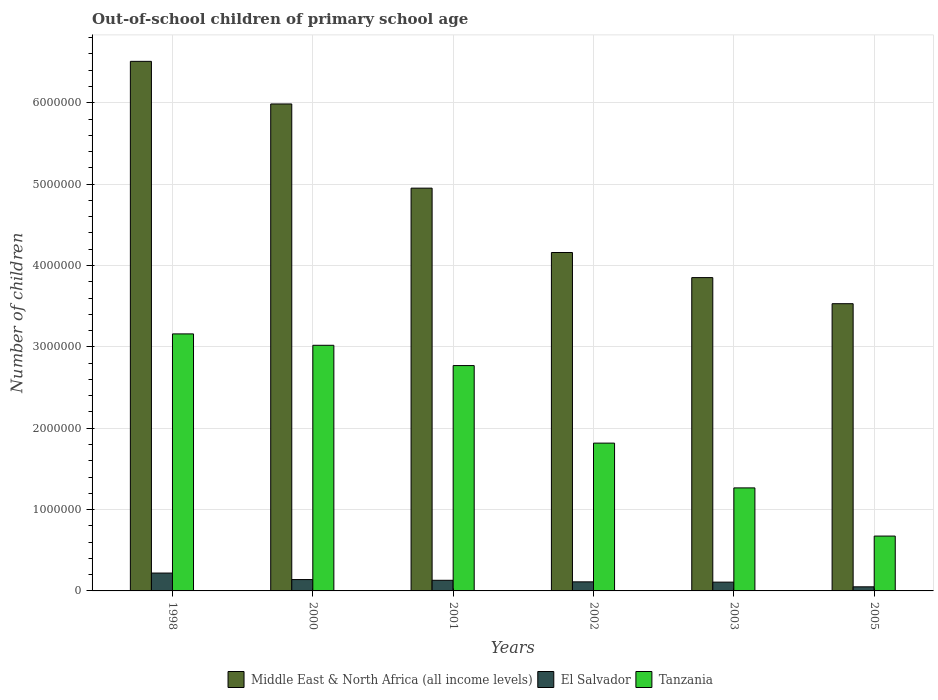Are the number of bars on each tick of the X-axis equal?
Your answer should be very brief. Yes. How many bars are there on the 2nd tick from the left?
Your answer should be very brief. 3. How many bars are there on the 4th tick from the right?
Your response must be concise. 3. What is the number of out-of-school children in Middle East & North Africa (all income levels) in 2001?
Ensure brevity in your answer.  4.95e+06. Across all years, what is the maximum number of out-of-school children in Tanzania?
Ensure brevity in your answer.  3.16e+06. Across all years, what is the minimum number of out-of-school children in Tanzania?
Offer a terse response. 6.74e+05. In which year was the number of out-of-school children in Tanzania minimum?
Keep it short and to the point. 2005. What is the total number of out-of-school children in El Salvador in the graph?
Provide a short and direct response. 7.60e+05. What is the difference between the number of out-of-school children in Tanzania in 2000 and that in 2001?
Offer a terse response. 2.49e+05. What is the difference between the number of out-of-school children in El Salvador in 2000 and the number of out-of-school children in Tanzania in 2001?
Give a very brief answer. -2.63e+06. What is the average number of out-of-school children in Middle East & North Africa (all income levels) per year?
Your answer should be very brief. 4.83e+06. In the year 2002, what is the difference between the number of out-of-school children in Middle East & North Africa (all income levels) and number of out-of-school children in El Salvador?
Your response must be concise. 4.05e+06. What is the ratio of the number of out-of-school children in Middle East & North Africa (all income levels) in 2001 to that in 2003?
Ensure brevity in your answer.  1.29. Is the number of out-of-school children in Tanzania in 2001 less than that in 2005?
Keep it short and to the point. No. What is the difference between the highest and the second highest number of out-of-school children in El Salvador?
Ensure brevity in your answer.  8.01e+04. What is the difference between the highest and the lowest number of out-of-school children in Middle East & North Africa (all income levels)?
Give a very brief answer. 2.98e+06. What does the 2nd bar from the left in 2000 represents?
Ensure brevity in your answer.  El Salvador. What does the 3rd bar from the right in 2002 represents?
Ensure brevity in your answer.  Middle East & North Africa (all income levels). Is it the case that in every year, the sum of the number of out-of-school children in Tanzania and number of out-of-school children in El Salvador is greater than the number of out-of-school children in Middle East & North Africa (all income levels)?
Provide a succinct answer. No. How many years are there in the graph?
Ensure brevity in your answer.  6. What is the difference between two consecutive major ticks on the Y-axis?
Your answer should be very brief. 1.00e+06. Where does the legend appear in the graph?
Ensure brevity in your answer.  Bottom center. What is the title of the graph?
Your answer should be very brief. Out-of-school children of primary school age. What is the label or title of the X-axis?
Keep it short and to the point. Years. What is the label or title of the Y-axis?
Provide a short and direct response. Number of children. What is the Number of children of Middle East & North Africa (all income levels) in 1998?
Give a very brief answer. 6.51e+06. What is the Number of children of El Salvador in 1998?
Ensure brevity in your answer.  2.20e+05. What is the Number of children of Tanzania in 1998?
Provide a short and direct response. 3.16e+06. What is the Number of children in Middle East & North Africa (all income levels) in 2000?
Your response must be concise. 5.99e+06. What is the Number of children of El Salvador in 2000?
Give a very brief answer. 1.39e+05. What is the Number of children in Tanzania in 2000?
Make the answer very short. 3.02e+06. What is the Number of children in Middle East & North Africa (all income levels) in 2001?
Offer a terse response. 4.95e+06. What is the Number of children of El Salvador in 2001?
Make the answer very short. 1.31e+05. What is the Number of children in Tanzania in 2001?
Your response must be concise. 2.77e+06. What is the Number of children of Middle East & North Africa (all income levels) in 2002?
Keep it short and to the point. 4.16e+06. What is the Number of children in El Salvador in 2002?
Make the answer very short. 1.11e+05. What is the Number of children of Tanzania in 2002?
Your answer should be compact. 1.82e+06. What is the Number of children in Middle East & North Africa (all income levels) in 2003?
Make the answer very short. 3.85e+06. What is the Number of children of El Salvador in 2003?
Your answer should be very brief. 1.08e+05. What is the Number of children of Tanzania in 2003?
Offer a terse response. 1.27e+06. What is the Number of children in Middle East & North Africa (all income levels) in 2005?
Provide a succinct answer. 3.53e+06. What is the Number of children of El Salvador in 2005?
Offer a very short reply. 5.04e+04. What is the Number of children in Tanzania in 2005?
Your answer should be compact. 6.74e+05. Across all years, what is the maximum Number of children of Middle East & North Africa (all income levels)?
Your answer should be very brief. 6.51e+06. Across all years, what is the maximum Number of children in El Salvador?
Provide a short and direct response. 2.20e+05. Across all years, what is the maximum Number of children in Tanzania?
Provide a short and direct response. 3.16e+06. Across all years, what is the minimum Number of children in Middle East & North Africa (all income levels)?
Offer a terse response. 3.53e+06. Across all years, what is the minimum Number of children of El Salvador?
Offer a very short reply. 5.04e+04. Across all years, what is the minimum Number of children of Tanzania?
Offer a terse response. 6.74e+05. What is the total Number of children in Middle East & North Africa (all income levels) in the graph?
Offer a terse response. 2.90e+07. What is the total Number of children in El Salvador in the graph?
Your answer should be compact. 7.60e+05. What is the total Number of children of Tanzania in the graph?
Provide a short and direct response. 1.27e+07. What is the difference between the Number of children in Middle East & North Africa (all income levels) in 1998 and that in 2000?
Provide a short and direct response. 5.24e+05. What is the difference between the Number of children in El Salvador in 1998 and that in 2000?
Keep it short and to the point. 8.01e+04. What is the difference between the Number of children in Tanzania in 1998 and that in 2000?
Your response must be concise. 1.40e+05. What is the difference between the Number of children of Middle East & North Africa (all income levels) in 1998 and that in 2001?
Your answer should be very brief. 1.56e+06. What is the difference between the Number of children of El Salvador in 1998 and that in 2001?
Your answer should be compact. 8.89e+04. What is the difference between the Number of children in Tanzania in 1998 and that in 2001?
Offer a terse response. 3.89e+05. What is the difference between the Number of children in Middle East & North Africa (all income levels) in 1998 and that in 2002?
Keep it short and to the point. 2.35e+06. What is the difference between the Number of children of El Salvador in 1998 and that in 2002?
Your response must be concise. 1.08e+05. What is the difference between the Number of children of Tanzania in 1998 and that in 2002?
Make the answer very short. 1.34e+06. What is the difference between the Number of children in Middle East & North Africa (all income levels) in 1998 and that in 2003?
Your response must be concise. 2.66e+06. What is the difference between the Number of children in El Salvador in 1998 and that in 2003?
Your answer should be compact. 1.12e+05. What is the difference between the Number of children in Tanzania in 1998 and that in 2003?
Give a very brief answer. 1.89e+06. What is the difference between the Number of children in Middle East & North Africa (all income levels) in 1998 and that in 2005?
Offer a very short reply. 2.98e+06. What is the difference between the Number of children in El Salvador in 1998 and that in 2005?
Your answer should be very brief. 1.69e+05. What is the difference between the Number of children in Tanzania in 1998 and that in 2005?
Ensure brevity in your answer.  2.48e+06. What is the difference between the Number of children of Middle East & North Africa (all income levels) in 2000 and that in 2001?
Give a very brief answer. 1.03e+06. What is the difference between the Number of children of El Salvador in 2000 and that in 2001?
Make the answer very short. 8801. What is the difference between the Number of children in Tanzania in 2000 and that in 2001?
Keep it short and to the point. 2.49e+05. What is the difference between the Number of children of Middle East & North Africa (all income levels) in 2000 and that in 2002?
Give a very brief answer. 1.83e+06. What is the difference between the Number of children of El Salvador in 2000 and that in 2002?
Make the answer very short. 2.80e+04. What is the difference between the Number of children in Tanzania in 2000 and that in 2002?
Offer a very short reply. 1.20e+06. What is the difference between the Number of children of Middle East & North Africa (all income levels) in 2000 and that in 2003?
Provide a succinct answer. 2.13e+06. What is the difference between the Number of children in El Salvador in 2000 and that in 2003?
Make the answer very short. 3.15e+04. What is the difference between the Number of children in Tanzania in 2000 and that in 2003?
Your answer should be very brief. 1.75e+06. What is the difference between the Number of children of Middle East & North Africa (all income levels) in 2000 and that in 2005?
Offer a very short reply. 2.45e+06. What is the difference between the Number of children of El Salvador in 2000 and that in 2005?
Make the answer very short. 8.91e+04. What is the difference between the Number of children in Tanzania in 2000 and that in 2005?
Your answer should be very brief. 2.35e+06. What is the difference between the Number of children of Middle East & North Africa (all income levels) in 2001 and that in 2002?
Keep it short and to the point. 7.91e+05. What is the difference between the Number of children in El Salvador in 2001 and that in 2002?
Provide a succinct answer. 1.92e+04. What is the difference between the Number of children of Tanzania in 2001 and that in 2002?
Provide a succinct answer. 9.53e+05. What is the difference between the Number of children in Middle East & North Africa (all income levels) in 2001 and that in 2003?
Keep it short and to the point. 1.10e+06. What is the difference between the Number of children of El Salvador in 2001 and that in 2003?
Offer a very short reply. 2.27e+04. What is the difference between the Number of children of Tanzania in 2001 and that in 2003?
Offer a very short reply. 1.50e+06. What is the difference between the Number of children in Middle East & North Africa (all income levels) in 2001 and that in 2005?
Offer a terse response. 1.42e+06. What is the difference between the Number of children in El Salvador in 2001 and that in 2005?
Provide a short and direct response. 8.03e+04. What is the difference between the Number of children of Tanzania in 2001 and that in 2005?
Provide a succinct answer. 2.10e+06. What is the difference between the Number of children in Middle East & North Africa (all income levels) in 2002 and that in 2003?
Ensure brevity in your answer.  3.09e+05. What is the difference between the Number of children of El Salvador in 2002 and that in 2003?
Your response must be concise. 3536. What is the difference between the Number of children in Tanzania in 2002 and that in 2003?
Keep it short and to the point. 5.50e+05. What is the difference between the Number of children in Middle East & North Africa (all income levels) in 2002 and that in 2005?
Your answer should be compact. 6.29e+05. What is the difference between the Number of children in El Salvador in 2002 and that in 2005?
Offer a very short reply. 6.11e+04. What is the difference between the Number of children in Tanzania in 2002 and that in 2005?
Keep it short and to the point. 1.14e+06. What is the difference between the Number of children of Middle East & North Africa (all income levels) in 2003 and that in 2005?
Make the answer very short. 3.21e+05. What is the difference between the Number of children in El Salvador in 2003 and that in 2005?
Provide a short and direct response. 5.76e+04. What is the difference between the Number of children of Tanzania in 2003 and that in 2005?
Your answer should be compact. 5.92e+05. What is the difference between the Number of children in Middle East & North Africa (all income levels) in 1998 and the Number of children in El Salvador in 2000?
Your answer should be very brief. 6.37e+06. What is the difference between the Number of children in Middle East & North Africa (all income levels) in 1998 and the Number of children in Tanzania in 2000?
Make the answer very short. 3.49e+06. What is the difference between the Number of children of El Salvador in 1998 and the Number of children of Tanzania in 2000?
Provide a succinct answer. -2.80e+06. What is the difference between the Number of children in Middle East & North Africa (all income levels) in 1998 and the Number of children in El Salvador in 2001?
Provide a succinct answer. 6.38e+06. What is the difference between the Number of children of Middle East & North Africa (all income levels) in 1998 and the Number of children of Tanzania in 2001?
Your answer should be compact. 3.74e+06. What is the difference between the Number of children of El Salvador in 1998 and the Number of children of Tanzania in 2001?
Make the answer very short. -2.55e+06. What is the difference between the Number of children in Middle East & North Africa (all income levels) in 1998 and the Number of children in El Salvador in 2002?
Give a very brief answer. 6.40e+06. What is the difference between the Number of children of Middle East & North Africa (all income levels) in 1998 and the Number of children of Tanzania in 2002?
Offer a terse response. 4.69e+06. What is the difference between the Number of children of El Salvador in 1998 and the Number of children of Tanzania in 2002?
Provide a succinct answer. -1.60e+06. What is the difference between the Number of children in Middle East & North Africa (all income levels) in 1998 and the Number of children in El Salvador in 2003?
Offer a very short reply. 6.40e+06. What is the difference between the Number of children of Middle East & North Africa (all income levels) in 1998 and the Number of children of Tanzania in 2003?
Provide a short and direct response. 5.24e+06. What is the difference between the Number of children of El Salvador in 1998 and the Number of children of Tanzania in 2003?
Your response must be concise. -1.05e+06. What is the difference between the Number of children in Middle East & North Africa (all income levels) in 1998 and the Number of children in El Salvador in 2005?
Offer a very short reply. 6.46e+06. What is the difference between the Number of children in Middle East & North Africa (all income levels) in 1998 and the Number of children in Tanzania in 2005?
Your answer should be compact. 5.83e+06. What is the difference between the Number of children of El Salvador in 1998 and the Number of children of Tanzania in 2005?
Give a very brief answer. -4.55e+05. What is the difference between the Number of children of Middle East & North Africa (all income levels) in 2000 and the Number of children of El Salvador in 2001?
Your answer should be compact. 5.85e+06. What is the difference between the Number of children in Middle East & North Africa (all income levels) in 2000 and the Number of children in Tanzania in 2001?
Your answer should be very brief. 3.22e+06. What is the difference between the Number of children in El Salvador in 2000 and the Number of children in Tanzania in 2001?
Provide a succinct answer. -2.63e+06. What is the difference between the Number of children in Middle East & North Africa (all income levels) in 2000 and the Number of children in El Salvador in 2002?
Keep it short and to the point. 5.87e+06. What is the difference between the Number of children in Middle East & North Africa (all income levels) in 2000 and the Number of children in Tanzania in 2002?
Give a very brief answer. 4.17e+06. What is the difference between the Number of children in El Salvador in 2000 and the Number of children in Tanzania in 2002?
Give a very brief answer. -1.68e+06. What is the difference between the Number of children of Middle East & North Africa (all income levels) in 2000 and the Number of children of El Salvador in 2003?
Offer a very short reply. 5.88e+06. What is the difference between the Number of children in Middle East & North Africa (all income levels) in 2000 and the Number of children in Tanzania in 2003?
Your answer should be very brief. 4.72e+06. What is the difference between the Number of children in El Salvador in 2000 and the Number of children in Tanzania in 2003?
Your answer should be very brief. -1.13e+06. What is the difference between the Number of children of Middle East & North Africa (all income levels) in 2000 and the Number of children of El Salvador in 2005?
Your answer should be compact. 5.94e+06. What is the difference between the Number of children of Middle East & North Africa (all income levels) in 2000 and the Number of children of Tanzania in 2005?
Your answer should be compact. 5.31e+06. What is the difference between the Number of children of El Salvador in 2000 and the Number of children of Tanzania in 2005?
Make the answer very short. -5.35e+05. What is the difference between the Number of children of Middle East & North Africa (all income levels) in 2001 and the Number of children of El Salvador in 2002?
Ensure brevity in your answer.  4.84e+06. What is the difference between the Number of children of Middle East & North Africa (all income levels) in 2001 and the Number of children of Tanzania in 2002?
Give a very brief answer. 3.13e+06. What is the difference between the Number of children in El Salvador in 2001 and the Number of children in Tanzania in 2002?
Your answer should be very brief. -1.69e+06. What is the difference between the Number of children in Middle East & North Africa (all income levels) in 2001 and the Number of children in El Salvador in 2003?
Your answer should be compact. 4.84e+06. What is the difference between the Number of children of Middle East & North Africa (all income levels) in 2001 and the Number of children of Tanzania in 2003?
Your response must be concise. 3.68e+06. What is the difference between the Number of children of El Salvador in 2001 and the Number of children of Tanzania in 2003?
Make the answer very short. -1.14e+06. What is the difference between the Number of children of Middle East & North Africa (all income levels) in 2001 and the Number of children of El Salvador in 2005?
Your answer should be very brief. 4.90e+06. What is the difference between the Number of children of Middle East & North Africa (all income levels) in 2001 and the Number of children of Tanzania in 2005?
Your answer should be very brief. 4.28e+06. What is the difference between the Number of children in El Salvador in 2001 and the Number of children in Tanzania in 2005?
Offer a very short reply. -5.43e+05. What is the difference between the Number of children in Middle East & North Africa (all income levels) in 2002 and the Number of children in El Salvador in 2003?
Your answer should be compact. 4.05e+06. What is the difference between the Number of children of Middle East & North Africa (all income levels) in 2002 and the Number of children of Tanzania in 2003?
Keep it short and to the point. 2.89e+06. What is the difference between the Number of children in El Salvador in 2002 and the Number of children in Tanzania in 2003?
Provide a short and direct response. -1.15e+06. What is the difference between the Number of children of Middle East & North Africa (all income levels) in 2002 and the Number of children of El Salvador in 2005?
Keep it short and to the point. 4.11e+06. What is the difference between the Number of children of Middle East & North Africa (all income levels) in 2002 and the Number of children of Tanzania in 2005?
Provide a short and direct response. 3.49e+06. What is the difference between the Number of children in El Salvador in 2002 and the Number of children in Tanzania in 2005?
Keep it short and to the point. -5.63e+05. What is the difference between the Number of children of Middle East & North Africa (all income levels) in 2003 and the Number of children of El Salvador in 2005?
Keep it short and to the point. 3.80e+06. What is the difference between the Number of children in Middle East & North Africa (all income levels) in 2003 and the Number of children in Tanzania in 2005?
Provide a succinct answer. 3.18e+06. What is the difference between the Number of children of El Salvador in 2003 and the Number of children of Tanzania in 2005?
Make the answer very short. -5.66e+05. What is the average Number of children in Middle East & North Africa (all income levels) per year?
Keep it short and to the point. 4.83e+06. What is the average Number of children in El Salvador per year?
Your answer should be very brief. 1.27e+05. What is the average Number of children in Tanzania per year?
Offer a very short reply. 2.12e+06. In the year 1998, what is the difference between the Number of children of Middle East & North Africa (all income levels) and Number of children of El Salvador?
Keep it short and to the point. 6.29e+06. In the year 1998, what is the difference between the Number of children in Middle East & North Africa (all income levels) and Number of children in Tanzania?
Your answer should be very brief. 3.35e+06. In the year 1998, what is the difference between the Number of children of El Salvador and Number of children of Tanzania?
Make the answer very short. -2.94e+06. In the year 2000, what is the difference between the Number of children in Middle East & North Africa (all income levels) and Number of children in El Salvador?
Your answer should be very brief. 5.85e+06. In the year 2000, what is the difference between the Number of children of Middle East & North Africa (all income levels) and Number of children of Tanzania?
Provide a succinct answer. 2.97e+06. In the year 2000, what is the difference between the Number of children in El Salvador and Number of children in Tanzania?
Your response must be concise. -2.88e+06. In the year 2001, what is the difference between the Number of children in Middle East & North Africa (all income levels) and Number of children in El Salvador?
Give a very brief answer. 4.82e+06. In the year 2001, what is the difference between the Number of children in Middle East & North Africa (all income levels) and Number of children in Tanzania?
Offer a very short reply. 2.18e+06. In the year 2001, what is the difference between the Number of children of El Salvador and Number of children of Tanzania?
Provide a short and direct response. -2.64e+06. In the year 2002, what is the difference between the Number of children of Middle East & North Africa (all income levels) and Number of children of El Salvador?
Offer a very short reply. 4.05e+06. In the year 2002, what is the difference between the Number of children in Middle East & North Africa (all income levels) and Number of children in Tanzania?
Your response must be concise. 2.34e+06. In the year 2002, what is the difference between the Number of children of El Salvador and Number of children of Tanzania?
Offer a terse response. -1.71e+06. In the year 2003, what is the difference between the Number of children in Middle East & North Africa (all income levels) and Number of children in El Salvador?
Provide a short and direct response. 3.74e+06. In the year 2003, what is the difference between the Number of children in Middle East & North Africa (all income levels) and Number of children in Tanzania?
Ensure brevity in your answer.  2.58e+06. In the year 2003, what is the difference between the Number of children in El Salvador and Number of children in Tanzania?
Offer a very short reply. -1.16e+06. In the year 2005, what is the difference between the Number of children in Middle East & North Africa (all income levels) and Number of children in El Salvador?
Offer a very short reply. 3.48e+06. In the year 2005, what is the difference between the Number of children of Middle East & North Africa (all income levels) and Number of children of Tanzania?
Your response must be concise. 2.86e+06. In the year 2005, what is the difference between the Number of children of El Salvador and Number of children of Tanzania?
Give a very brief answer. -6.24e+05. What is the ratio of the Number of children of Middle East & North Africa (all income levels) in 1998 to that in 2000?
Give a very brief answer. 1.09. What is the ratio of the Number of children in El Salvador in 1998 to that in 2000?
Provide a succinct answer. 1.57. What is the ratio of the Number of children in Tanzania in 1998 to that in 2000?
Ensure brevity in your answer.  1.05. What is the ratio of the Number of children in Middle East & North Africa (all income levels) in 1998 to that in 2001?
Provide a succinct answer. 1.31. What is the ratio of the Number of children of El Salvador in 1998 to that in 2001?
Your answer should be very brief. 1.68. What is the ratio of the Number of children in Tanzania in 1998 to that in 2001?
Give a very brief answer. 1.14. What is the ratio of the Number of children of Middle East & North Africa (all income levels) in 1998 to that in 2002?
Give a very brief answer. 1.56. What is the ratio of the Number of children of El Salvador in 1998 to that in 2002?
Provide a succinct answer. 1.97. What is the ratio of the Number of children of Tanzania in 1998 to that in 2002?
Provide a succinct answer. 1.74. What is the ratio of the Number of children in Middle East & North Africa (all income levels) in 1998 to that in 2003?
Provide a succinct answer. 1.69. What is the ratio of the Number of children of El Salvador in 1998 to that in 2003?
Provide a succinct answer. 2.03. What is the ratio of the Number of children of Tanzania in 1998 to that in 2003?
Provide a succinct answer. 2.49. What is the ratio of the Number of children in Middle East & North Africa (all income levels) in 1998 to that in 2005?
Provide a short and direct response. 1.84. What is the ratio of the Number of children in El Salvador in 1998 to that in 2005?
Provide a short and direct response. 4.36. What is the ratio of the Number of children in Tanzania in 1998 to that in 2005?
Offer a very short reply. 4.69. What is the ratio of the Number of children in Middle East & North Africa (all income levels) in 2000 to that in 2001?
Your answer should be compact. 1.21. What is the ratio of the Number of children of El Salvador in 2000 to that in 2001?
Ensure brevity in your answer.  1.07. What is the ratio of the Number of children in Tanzania in 2000 to that in 2001?
Your answer should be very brief. 1.09. What is the ratio of the Number of children in Middle East & North Africa (all income levels) in 2000 to that in 2002?
Your answer should be compact. 1.44. What is the ratio of the Number of children of El Salvador in 2000 to that in 2002?
Make the answer very short. 1.25. What is the ratio of the Number of children in Tanzania in 2000 to that in 2002?
Offer a terse response. 1.66. What is the ratio of the Number of children of Middle East & North Africa (all income levels) in 2000 to that in 2003?
Make the answer very short. 1.55. What is the ratio of the Number of children of El Salvador in 2000 to that in 2003?
Make the answer very short. 1.29. What is the ratio of the Number of children of Tanzania in 2000 to that in 2003?
Give a very brief answer. 2.38. What is the ratio of the Number of children of Middle East & North Africa (all income levels) in 2000 to that in 2005?
Your response must be concise. 1.7. What is the ratio of the Number of children of El Salvador in 2000 to that in 2005?
Make the answer very short. 2.77. What is the ratio of the Number of children in Tanzania in 2000 to that in 2005?
Provide a short and direct response. 4.48. What is the ratio of the Number of children of Middle East & North Africa (all income levels) in 2001 to that in 2002?
Your answer should be compact. 1.19. What is the ratio of the Number of children in El Salvador in 2001 to that in 2002?
Make the answer very short. 1.17. What is the ratio of the Number of children in Tanzania in 2001 to that in 2002?
Offer a terse response. 1.52. What is the ratio of the Number of children of Middle East & North Africa (all income levels) in 2001 to that in 2003?
Keep it short and to the point. 1.29. What is the ratio of the Number of children in El Salvador in 2001 to that in 2003?
Your response must be concise. 1.21. What is the ratio of the Number of children in Tanzania in 2001 to that in 2003?
Your response must be concise. 2.19. What is the ratio of the Number of children of Middle East & North Africa (all income levels) in 2001 to that in 2005?
Your answer should be very brief. 1.4. What is the ratio of the Number of children in El Salvador in 2001 to that in 2005?
Offer a very short reply. 2.59. What is the ratio of the Number of children of Tanzania in 2001 to that in 2005?
Your response must be concise. 4.11. What is the ratio of the Number of children of Middle East & North Africa (all income levels) in 2002 to that in 2003?
Your response must be concise. 1.08. What is the ratio of the Number of children of El Salvador in 2002 to that in 2003?
Ensure brevity in your answer.  1.03. What is the ratio of the Number of children in Tanzania in 2002 to that in 2003?
Your answer should be compact. 1.43. What is the ratio of the Number of children of Middle East & North Africa (all income levels) in 2002 to that in 2005?
Give a very brief answer. 1.18. What is the ratio of the Number of children of El Salvador in 2002 to that in 2005?
Make the answer very short. 2.21. What is the ratio of the Number of children in Tanzania in 2002 to that in 2005?
Give a very brief answer. 2.7. What is the ratio of the Number of children in Middle East & North Africa (all income levels) in 2003 to that in 2005?
Offer a very short reply. 1.09. What is the ratio of the Number of children in El Salvador in 2003 to that in 2005?
Keep it short and to the point. 2.14. What is the ratio of the Number of children of Tanzania in 2003 to that in 2005?
Provide a short and direct response. 1.88. What is the difference between the highest and the second highest Number of children of Middle East & North Africa (all income levels)?
Give a very brief answer. 5.24e+05. What is the difference between the highest and the second highest Number of children in El Salvador?
Keep it short and to the point. 8.01e+04. What is the difference between the highest and the second highest Number of children in Tanzania?
Keep it short and to the point. 1.40e+05. What is the difference between the highest and the lowest Number of children in Middle East & North Africa (all income levels)?
Your answer should be compact. 2.98e+06. What is the difference between the highest and the lowest Number of children of El Salvador?
Provide a short and direct response. 1.69e+05. What is the difference between the highest and the lowest Number of children in Tanzania?
Provide a succinct answer. 2.48e+06. 